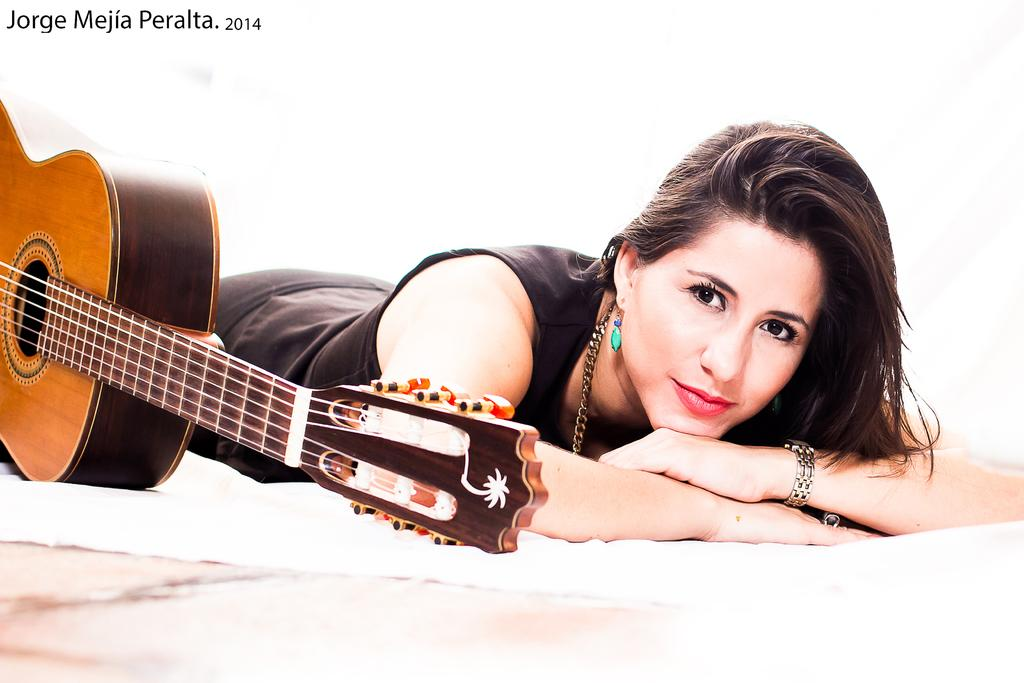What is the position of the person in the image? There is a person laying in the image. What is the person wearing in the image? The person is wearing a black dress. What other object can be seen in the image besides the person? There is a musical instrument in the image. What is the color of the background in the image? The background of the image is white. What type of jeans is the person wearing in the image? The person is not wearing jeans in the image; they are wearing a black dress. 